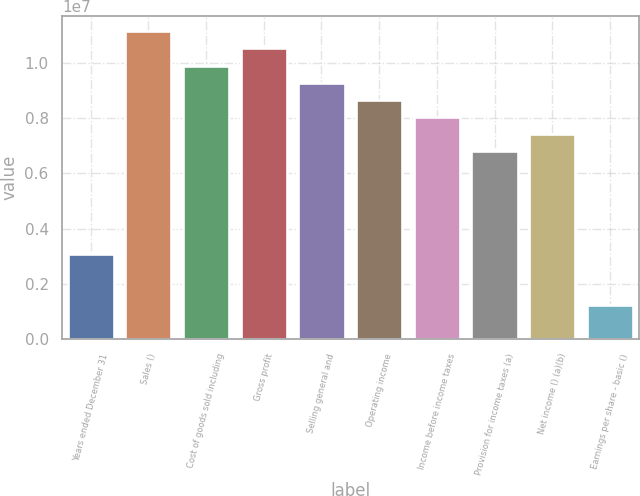Convert chart. <chart><loc_0><loc_0><loc_500><loc_500><bar_chart><fcel>Years ended December 31<fcel>Sales ()<fcel>Cost of goods sold including<fcel>Gross profit<fcel>Selling general and<fcel>Operating income<fcel>Income before income taxes<fcel>Provision for income taxes (a)<fcel>Net income () (a)(b)<fcel>Earnings per share - basic ()<nl><fcel>3.09109e+06<fcel>1.11279e+07<fcel>9.89149e+06<fcel>1.05097e+07<fcel>9.27327e+06<fcel>8.65506e+06<fcel>8.03684e+06<fcel>6.8004e+06<fcel>7.41862e+06<fcel>1.23644e+06<nl></chart> 